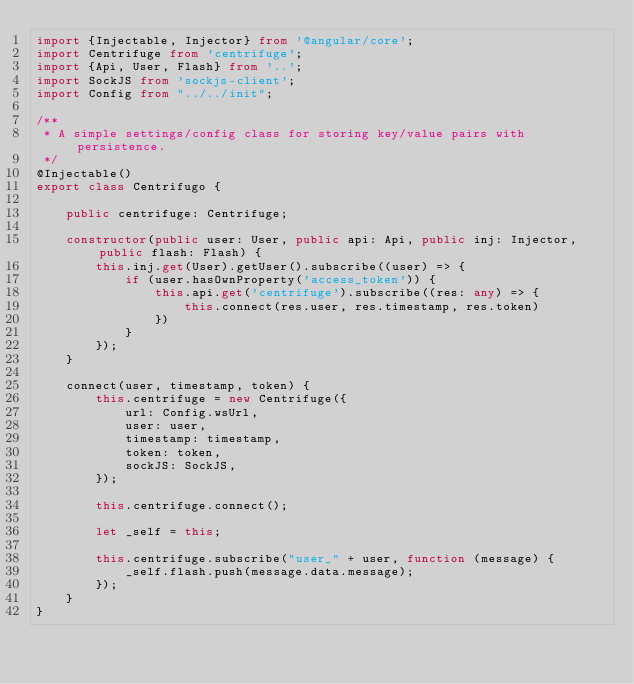<code> <loc_0><loc_0><loc_500><loc_500><_TypeScript_>import {Injectable, Injector} from '@angular/core';
import Centrifuge from 'centrifuge';
import {Api, User, Flash} from '..';
import SockJS from 'sockjs-client';
import Config from "../../init";

/**
 * A simple settings/config class for storing key/value pairs with persistence.
 */
@Injectable()
export class Centrifugo {

    public centrifuge: Centrifuge;

    constructor(public user: User, public api: Api, public inj: Injector, public flash: Flash) {
        this.inj.get(User).getUser().subscribe((user) => {
            if (user.hasOwnProperty('access_token')) {
                this.api.get('centrifuge').subscribe((res: any) => {
                    this.connect(res.user, res.timestamp, res.token)
                })
            }
        });
    }

    connect(user, timestamp, token) {
        this.centrifuge = new Centrifuge({
            url: Config.wsUrl,
            user: user,
            timestamp: timestamp,
            token: token,
            sockJS: SockJS,
        });

        this.centrifuge.connect();

        let _self = this;

        this.centrifuge.subscribe("user_" + user, function (message) {
            _self.flash.push(message.data.message);
        });
    }
}
</code> 